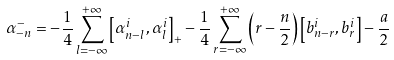<formula> <loc_0><loc_0><loc_500><loc_500>\alpha _ { - n } ^ { - } = - \frac { 1 } { 4 } \sum _ { l = - \infty } ^ { + \infty } \left [ \alpha _ { n - l } ^ { i } , \alpha _ { l } ^ { i } \right ] _ { + } - \frac { 1 } { 4 } \sum _ { r = - \infty } ^ { + \infty } \left ( r - \frac { n } { 2 } \right ) \left [ b _ { n - r } ^ { i } , b _ { r } ^ { i } \right ] - \frac { a } { 2 }</formula> 